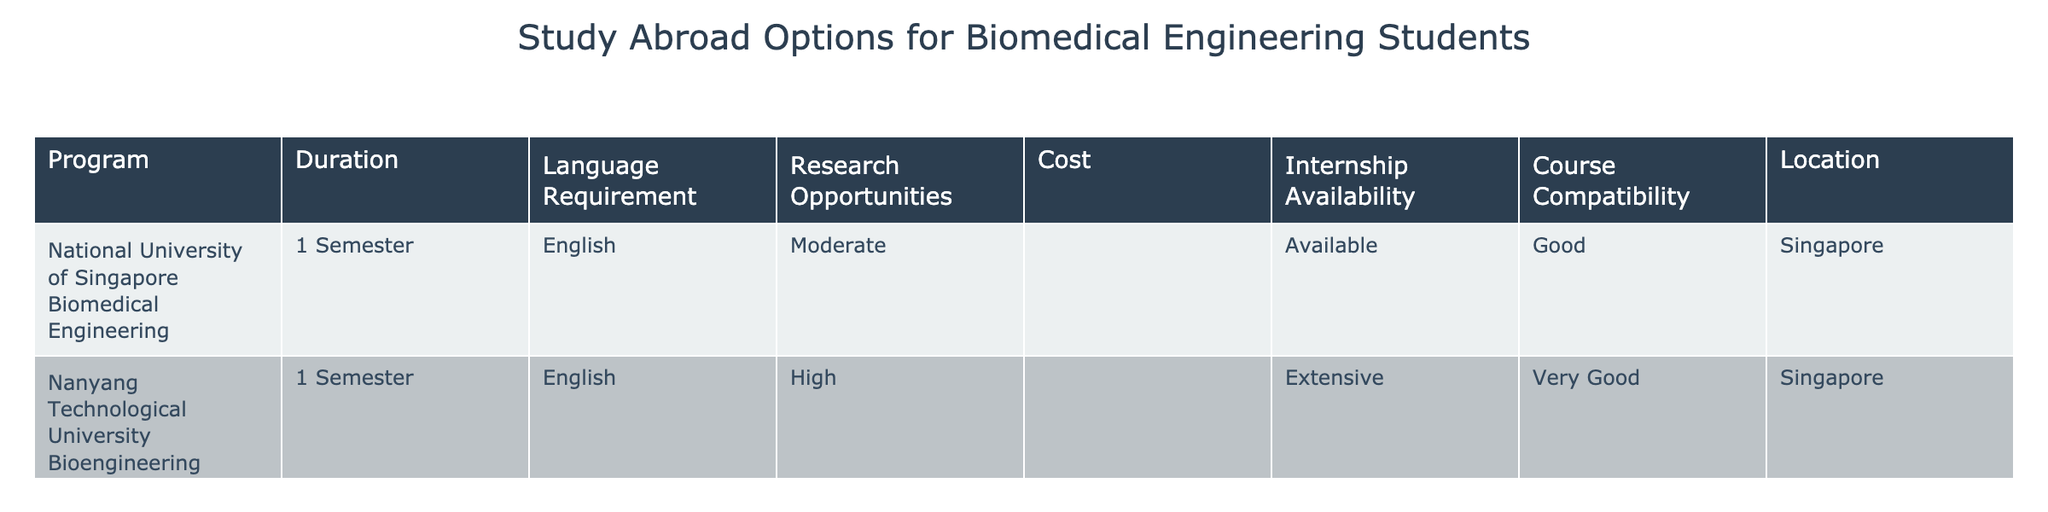What is the total cost of studying abroad at Nanyang Technological University? The table shows the cost for Nanyang Technological University Bioengineering as "$$". Since no specific numerical value is provided, we interpret "$$" as an indicator of a lower to moderate cost when compared to "Moderate" for the National University of Singapore. Therefore, the total cost is interpreted to be typical of a moderate range.
Answer: Moderate Is there a research opportunity available at the National University of Singapore? The table indicates that the National University of Singapore Biomedical Engineering program has "Moderate" research opportunities listed under Research Opportunities. Thus, there is definitely a research opportunity available, but it is not high.
Answer: Yes How many programs have internship availability? The table lists two programs, one at each university. Both indicate "Available" and "Extensive" respectively for internship availability. Therefore, both offer internships, amounting to a total of 2 programs.
Answer: 2 Which program has the highest research opportunities? By examining the Research Opportunities column, Nanyang Technological University has "High" while the National University of Singapore has "Moderate". Thus, the program with the highest research opportunities is Nanyang Technological University Bioengineering.
Answer: Nanyang Technological University Bioengineering Is there a language requirement for the National University of Singapore program? The table shows the language requirement for the National University of Singapore Biomedical Engineering program as "English". Thus, since a language requirement is specified, the answer is yes.
Answer: Yes What is the average level of course compatibility for the programs listed? The table lists course compatibility levels as "Good" for the National University of Singapore and "Very Good" for Nanyang Technological University. If we categorize "Good" as 3 and "Very Good" as 4, the average would be (3 + 4) / 2 = 3.5. Thus, the overall average compatibility level indicates a value between "Good" and "Very Good".
Answer: 3.5 How does the cost of the programs compare? The cost for the National University of Singapore program is noted as "$$$" and for Nanyang Technological University as "$$". Given that "$$$" indicates a higher cost than "$$", this implies that studying at the National University of Singapore will be more expensive than at Nanyang Technological University.
Answer: National University of Singapore is more expensive Which city offers both programs? The table clearly indicates that both programs are located in Singapore. It explicitly lists Singapore as the location for both the National University of Singapore Biomedical Engineering and the Nanyang Technological University Bioengineering program.
Answer: Singapore 